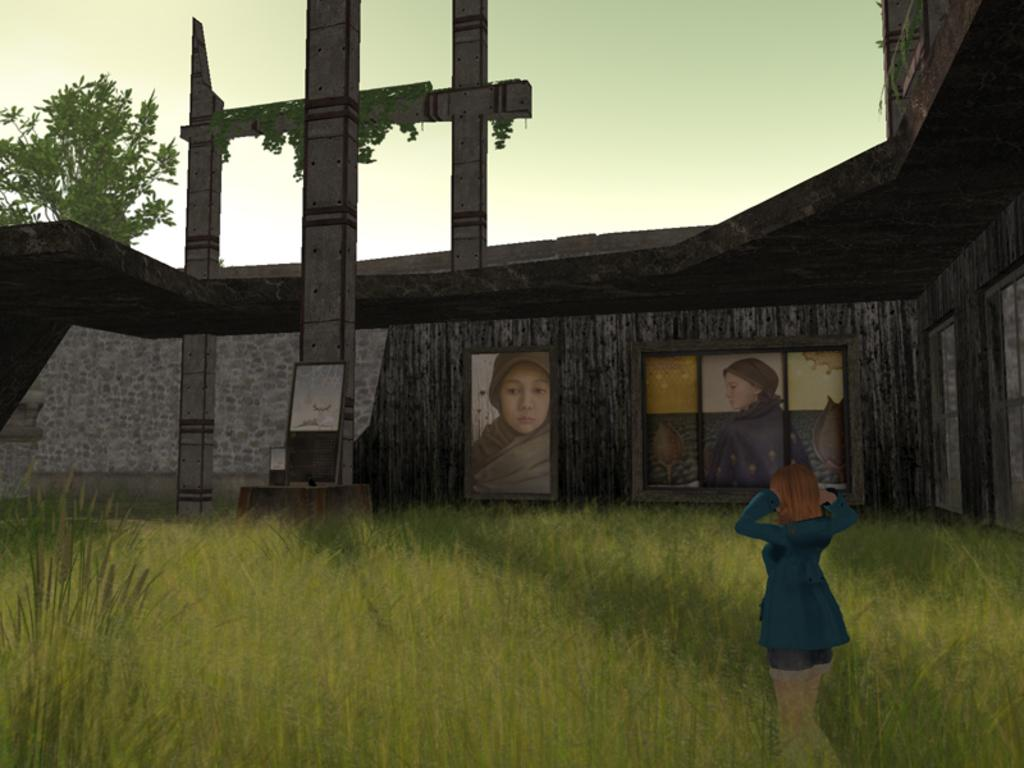What is the primary subject in the image? There is a woman standing in the image. What object can be seen near the woman? There is a glass in the image. What is hanging on the wall in the image? There is a frame on the wall in the image. What architectural feature is present in the image? There is a window in the image. What type of vegetation is visible in the image? There is a tree in the image. What can be seen in the background of the image? The sky is visible in the background of the image. What is the woman's temper like in the image? There is no information about the woman's temper in the image. 